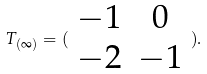<formula> <loc_0><loc_0><loc_500><loc_500>T _ { ( \infty ) } = ( \begin{array} { c c } - 1 & 0 \\ - 2 & - 1 \end{array} ) .</formula> 